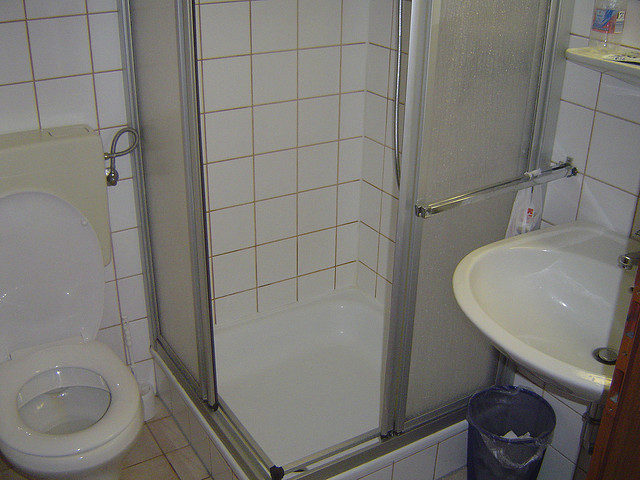What can you tell me about the functionalities in the bathroom? The bathroom appears to be compact yet well-organized. The toilet to the left is designed for basic sanitary functions. In the center, the shower cubicle offers an enclosed space for bathing, ensuring water doesn't splash over the rest of the bathroom. The shower likely features both hot and cold water options, controlled by a mixer valve. The sink on the right serves for washing hands and face, brushing teeth, and other hygiene-related activities. The small shelf above the sink is useful for holding toiletries, ensuring they are easily accessible. The wastebasket beneath the sink helps maintain cleanliness by providing a convenient place to dispose of trash. If this bathroom could talk, what would it say about its daily experiences? If this bathroom could talk, it might share about the bustling activity it witnesses each day. It would talk about the early morning routines where the shower is often filled with the sound of running water, the clattering of toothbrushes at the sink, and the occasional rush while people get ready for work or school. The toilet, always discreet, has its own share of busy moments. The bathroom shelf might chime in, noting how it quietly holds an array of toiletries, from fragrant shampoos to life-saving mouthwashes. Despite its small size, the bathroom is a sanctuary for daily rituals, a place of brief solitude and refreshment. 